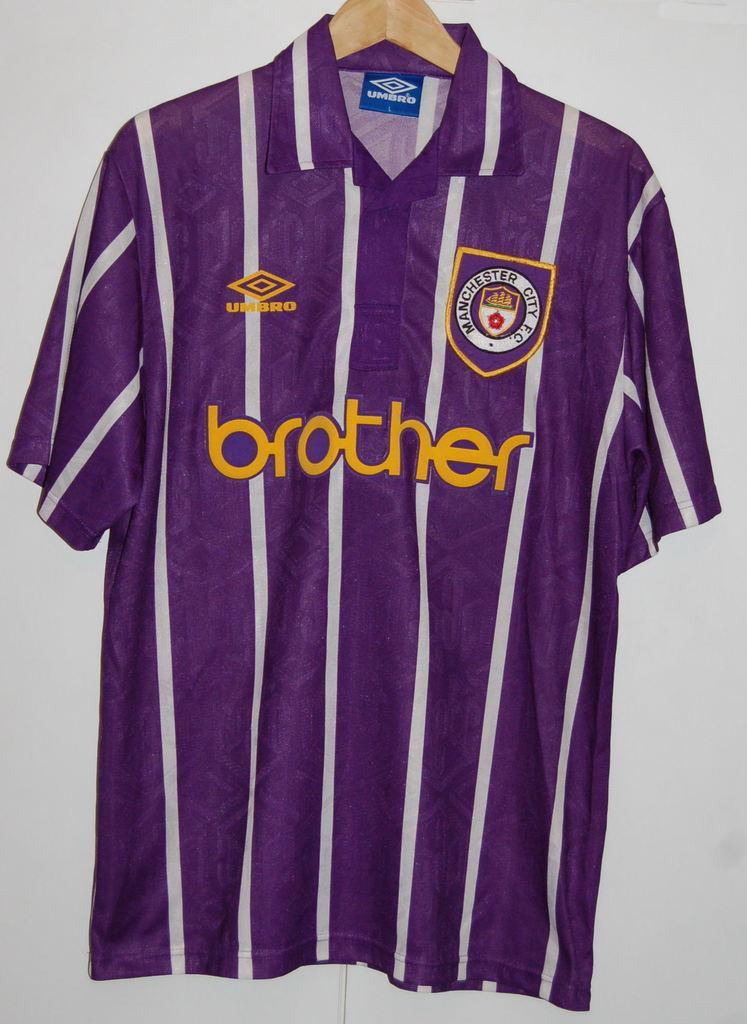Can you describe this image briefly? In this image we can see a t-shirt to a hanger. 